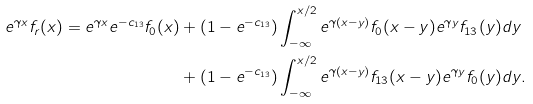<formula> <loc_0><loc_0><loc_500><loc_500>e ^ { \gamma x } f _ { r } ( x ) = e ^ { \gamma x } e ^ { - c _ { 1 3 } } f _ { 0 } ( x ) & + ( 1 - e ^ { - c _ { 1 3 } } ) \int _ { - \infty } ^ { x / 2 } e ^ { \gamma ( x - y ) } f _ { 0 } ( x - y ) e ^ { \gamma y } f _ { 1 3 } ( y ) d y \\ & + ( 1 - e ^ { - c _ { 1 3 } } ) \int _ { - \infty } ^ { x / 2 } e ^ { \gamma ( x - y ) } f _ { 1 3 } ( x - y ) e ^ { \gamma y } f _ { 0 } ( y ) d y .</formula> 